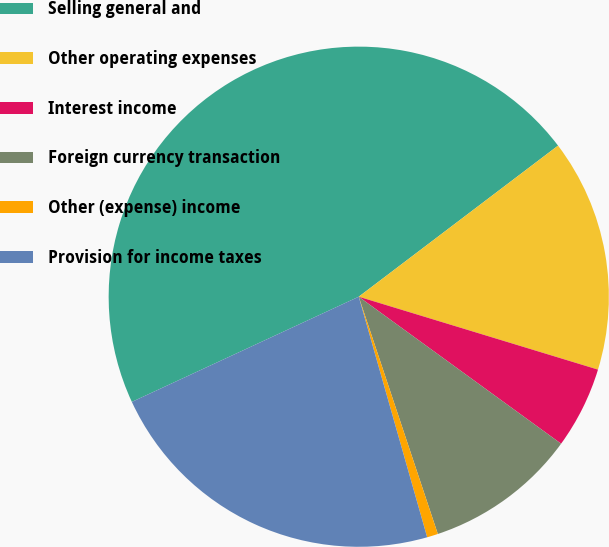<chart> <loc_0><loc_0><loc_500><loc_500><pie_chart><fcel>Selling general and<fcel>Other operating expenses<fcel>Interest income<fcel>Foreign currency transaction<fcel>Other (expense) income<fcel>Provision for income taxes<nl><fcel>46.58%<fcel>15.03%<fcel>5.29%<fcel>9.88%<fcel>0.71%<fcel>22.5%<nl></chart> 